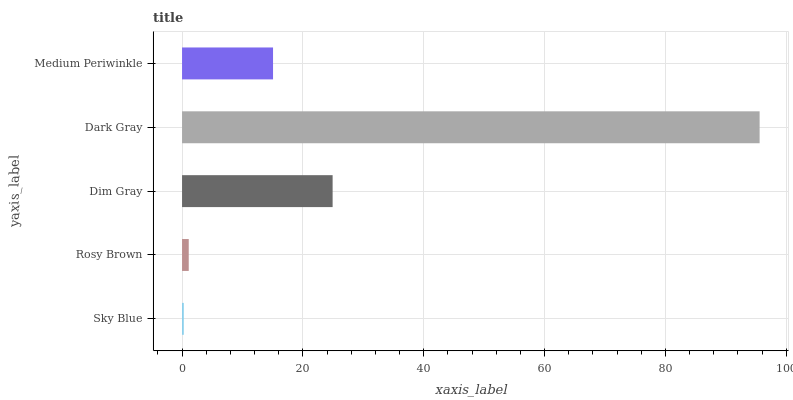Is Sky Blue the minimum?
Answer yes or no. Yes. Is Dark Gray the maximum?
Answer yes or no. Yes. Is Rosy Brown the minimum?
Answer yes or no. No. Is Rosy Brown the maximum?
Answer yes or no. No. Is Rosy Brown greater than Sky Blue?
Answer yes or no. Yes. Is Sky Blue less than Rosy Brown?
Answer yes or no. Yes. Is Sky Blue greater than Rosy Brown?
Answer yes or no. No. Is Rosy Brown less than Sky Blue?
Answer yes or no. No. Is Medium Periwinkle the high median?
Answer yes or no. Yes. Is Medium Periwinkle the low median?
Answer yes or no. Yes. Is Dim Gray the high median?
Answer yes or no. No. Is Dark Gray the low median?
Answer yes or no. No. 